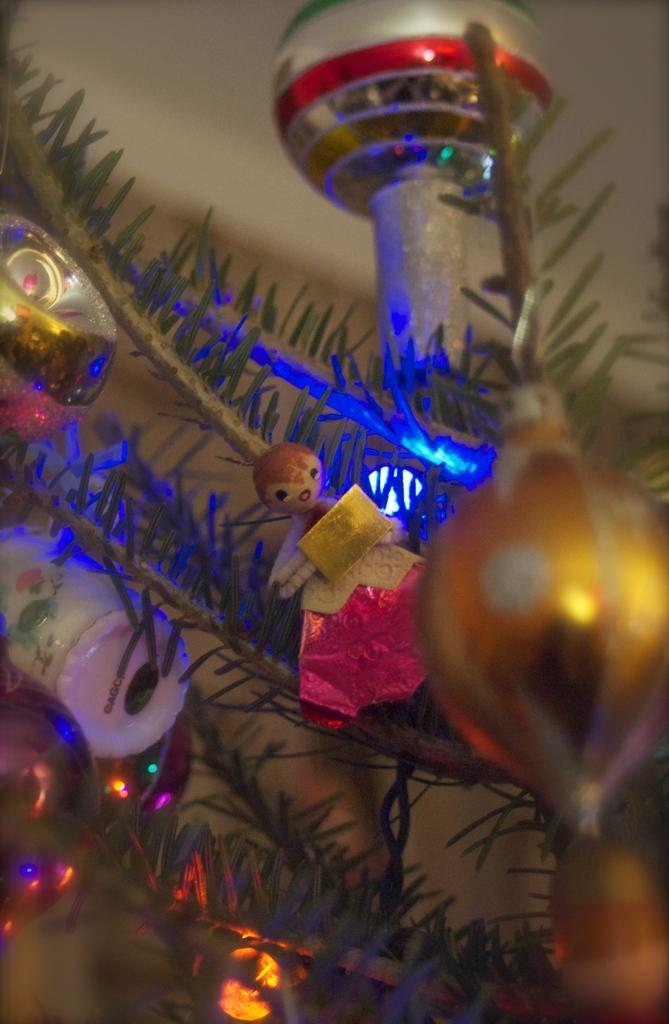What type of plant elements are present in the image? There are leaves on stems in the image. What else can be seen in the image besides the leaves? There is decoration and a doll in the image. Can you describe the doll's appearance in the image? The doll is blurred in the background. What is the best way to travel to this country in the image? There is no country present in the image, so it is not possible to determine the best way to travel to it. 